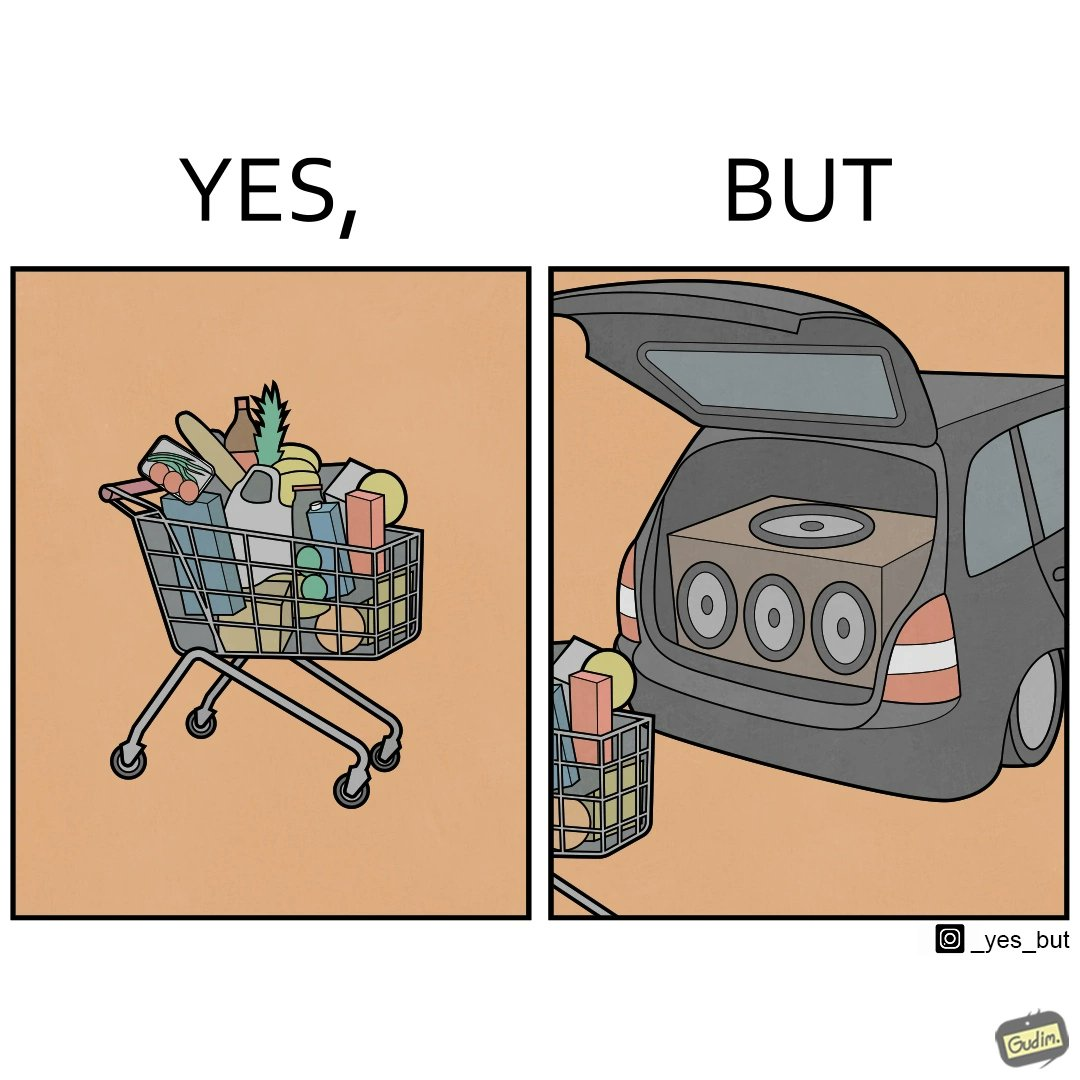Is this a satirical image? Yes, this image is satirical. 